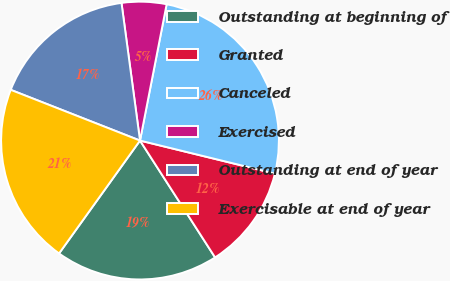Convert chart to OTSL. <chart><loc_0><loc_0><loc_500><loc_500><pie_chart><fcel>Outstanding at beginning of<fcel>Granted<fcel>Canceled<fcel>Exercised<fcel>Outstanding at end of year<fcel>Exercisable at end of year<nl><fcel>18.99%<fcel>12.09%<fcel>25.75%<fcel>5.2%<fcel>16.92%<fcel>21.05%<nl></chart> 